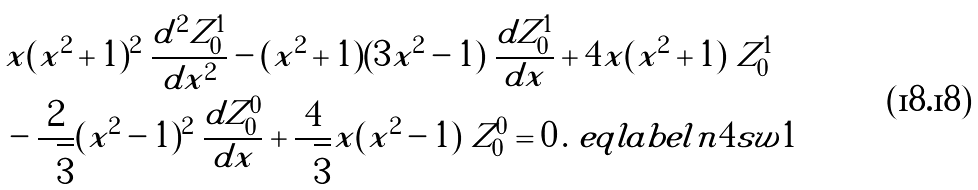Convert formula to latex. <formula><loc_0><loc_0><loc_500><loc_500>& x ( x ^ { 2 } + 1 ) ^ { 2 } \ \frac { d ^ { 2 } Z ^ { 1 } _ { 0 } } { d x ^ { 2 } } - ( x ^ { 2 } + 1 ) ( 3 x ^ { 2 } - 1 ) \ \frac { d Z ^ { 1 } _ { 0 } } { d x } + 4 x ( x ^ { 2 } + 1 ) \ Z ^ { 1 } _ { 0 } \\ & - \frac { 2 } { \sqrt { 3 } } ( x ^ { 2 } - 1 ) ^ { 2 } \ \frac { d Z ^ { 0 } _ { 0 } } { d x } + \frac { 4 } { \sqrt { 3 } } x ( x ^ { 2 } - 1 ) \ Z ^ { 0 } _ { 0 } = 0 \, . \ e q l a b e l { n 4 s w 1 }</formula> 